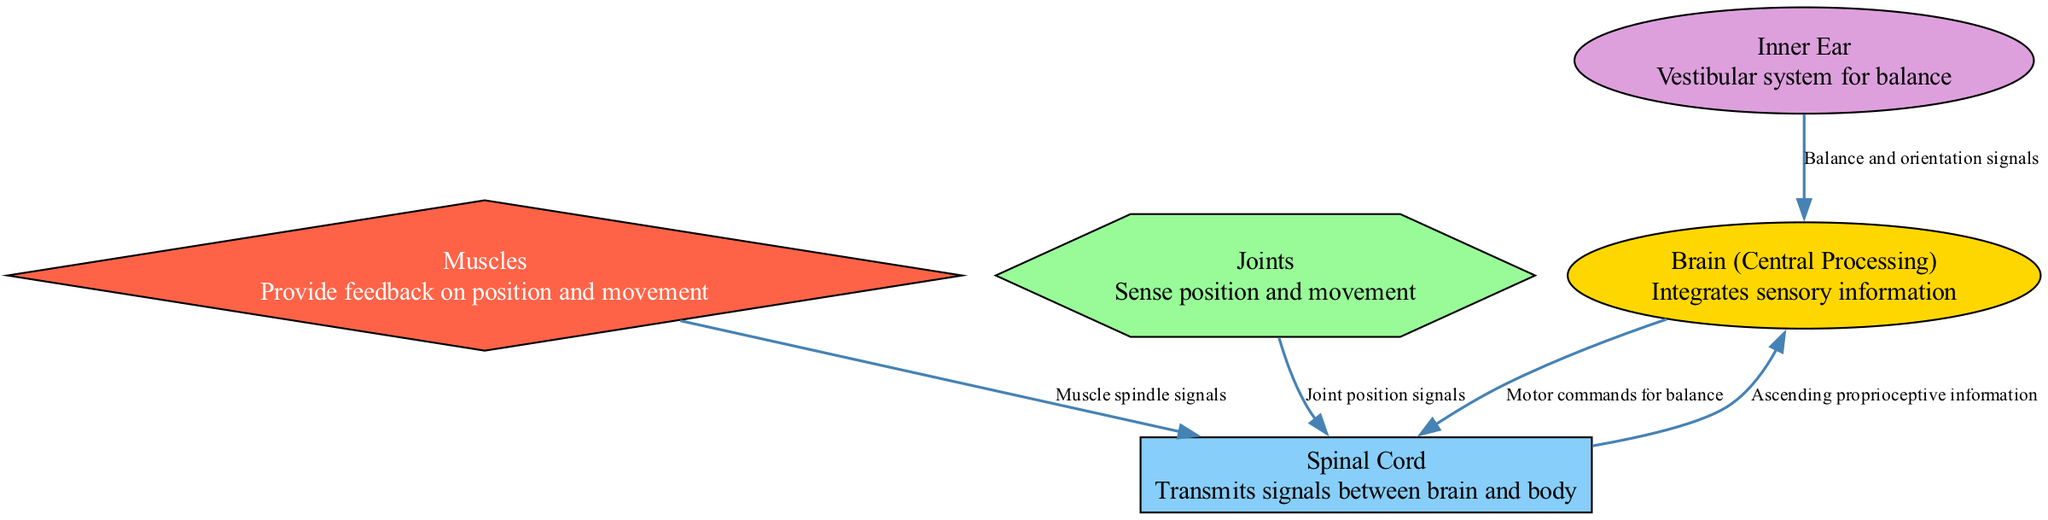What are the nodes in the diagram? The diagram includes five nodes: Brain, Spinal Cord, Muscles, Joints, and Inner Ear. These represent different components involved in proprioceptive pathways.
Answer: Brain, Spinal Cord, Muscles, Joints, Inner Ear How many edges are present in the diagram? The diagram contains four edges, representing the connections and flow of information between the nodes mentioned.
Answer: Four What signals do the muscles send? The muscles send muscle spindle signals to the spinal cord, providing information about muscle stretch and movement.
Answer: Muscle spindle signals Which component is responsible for balance? The Inner Ear is responsible for balance, integrating information related to balance and spatial orientation.
Answer: Inner Ear Which node receives both muscle spindle and joint position signals? Both muscle spindle signals from the muscles and joint position signals from the joints are transmitted to the spinal cord for processing.
Answer: Spinal Cord How does information flow from the spinal cord to the brain? The flow of information from the spinal cord to the brain is through ascending proprioceptive information, which communicates sensory data for integration.
Answer: Ascending proprioceptive information What type of signals does the inner ear send to the brain? The inner ear sends balance and orientation signals to the brain, which helps maintain equilibrium and spatial awareness.
Answer: Balance and orientation signals What commands does the brain send to the spinal cord? The brain sends motor commands for balance to the spinal cord in order to coordinate muscle actions that support posture and stability.
Answer: Motor commands for balance How many types of feedback information are integrated in the brain? The brain integrates three types of feedback information: muscle spindle signals, joint position signals, and balance/orientation signals from the inner ear.
Answer: Three 